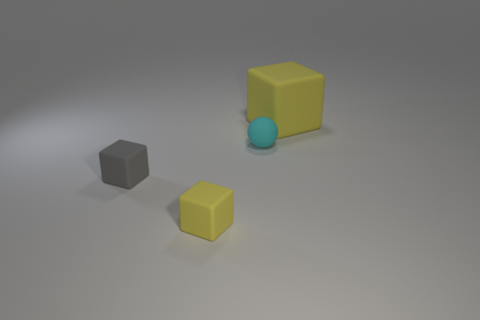Do the matte object that is in front of the gray thing and the big thing have the same color?
Your answer should be very brief. Yes. Are there any tiny things that have the same color as the big rubber object?
Make the answer very short. Yes. Is there a small matte sphere that is left of the matte cube behind the tiny gray matte cube?
Your answer should be compact. Yes. Are there any other things that have the same shape as the cyan rubber object?
Your answer should be compact. No. The other small object that is the same shape as the tiny yellow object is what color?
Give a very brief answer. Gray. How big is the cyan matte ball?
Offer a terse response. Small. Are there fewer tiny gray things that are behind the gray thing than tiny matte cylinders?
Provide a succinct answer. No. There is a yellow matte cube left of the yellow thing that is to the right of the small rubber ball; is there a cyan thing that is on the right side of it?
Keep it short and to the point. Yes. The other small block that is the same material as the gray cube is what color?
Ensure brevity in your answer.  Yellow. There is a rubber cube that is both behind the small yellow cube and right of the gray matte cube; what size is it?
Offer a terse response. Large. 